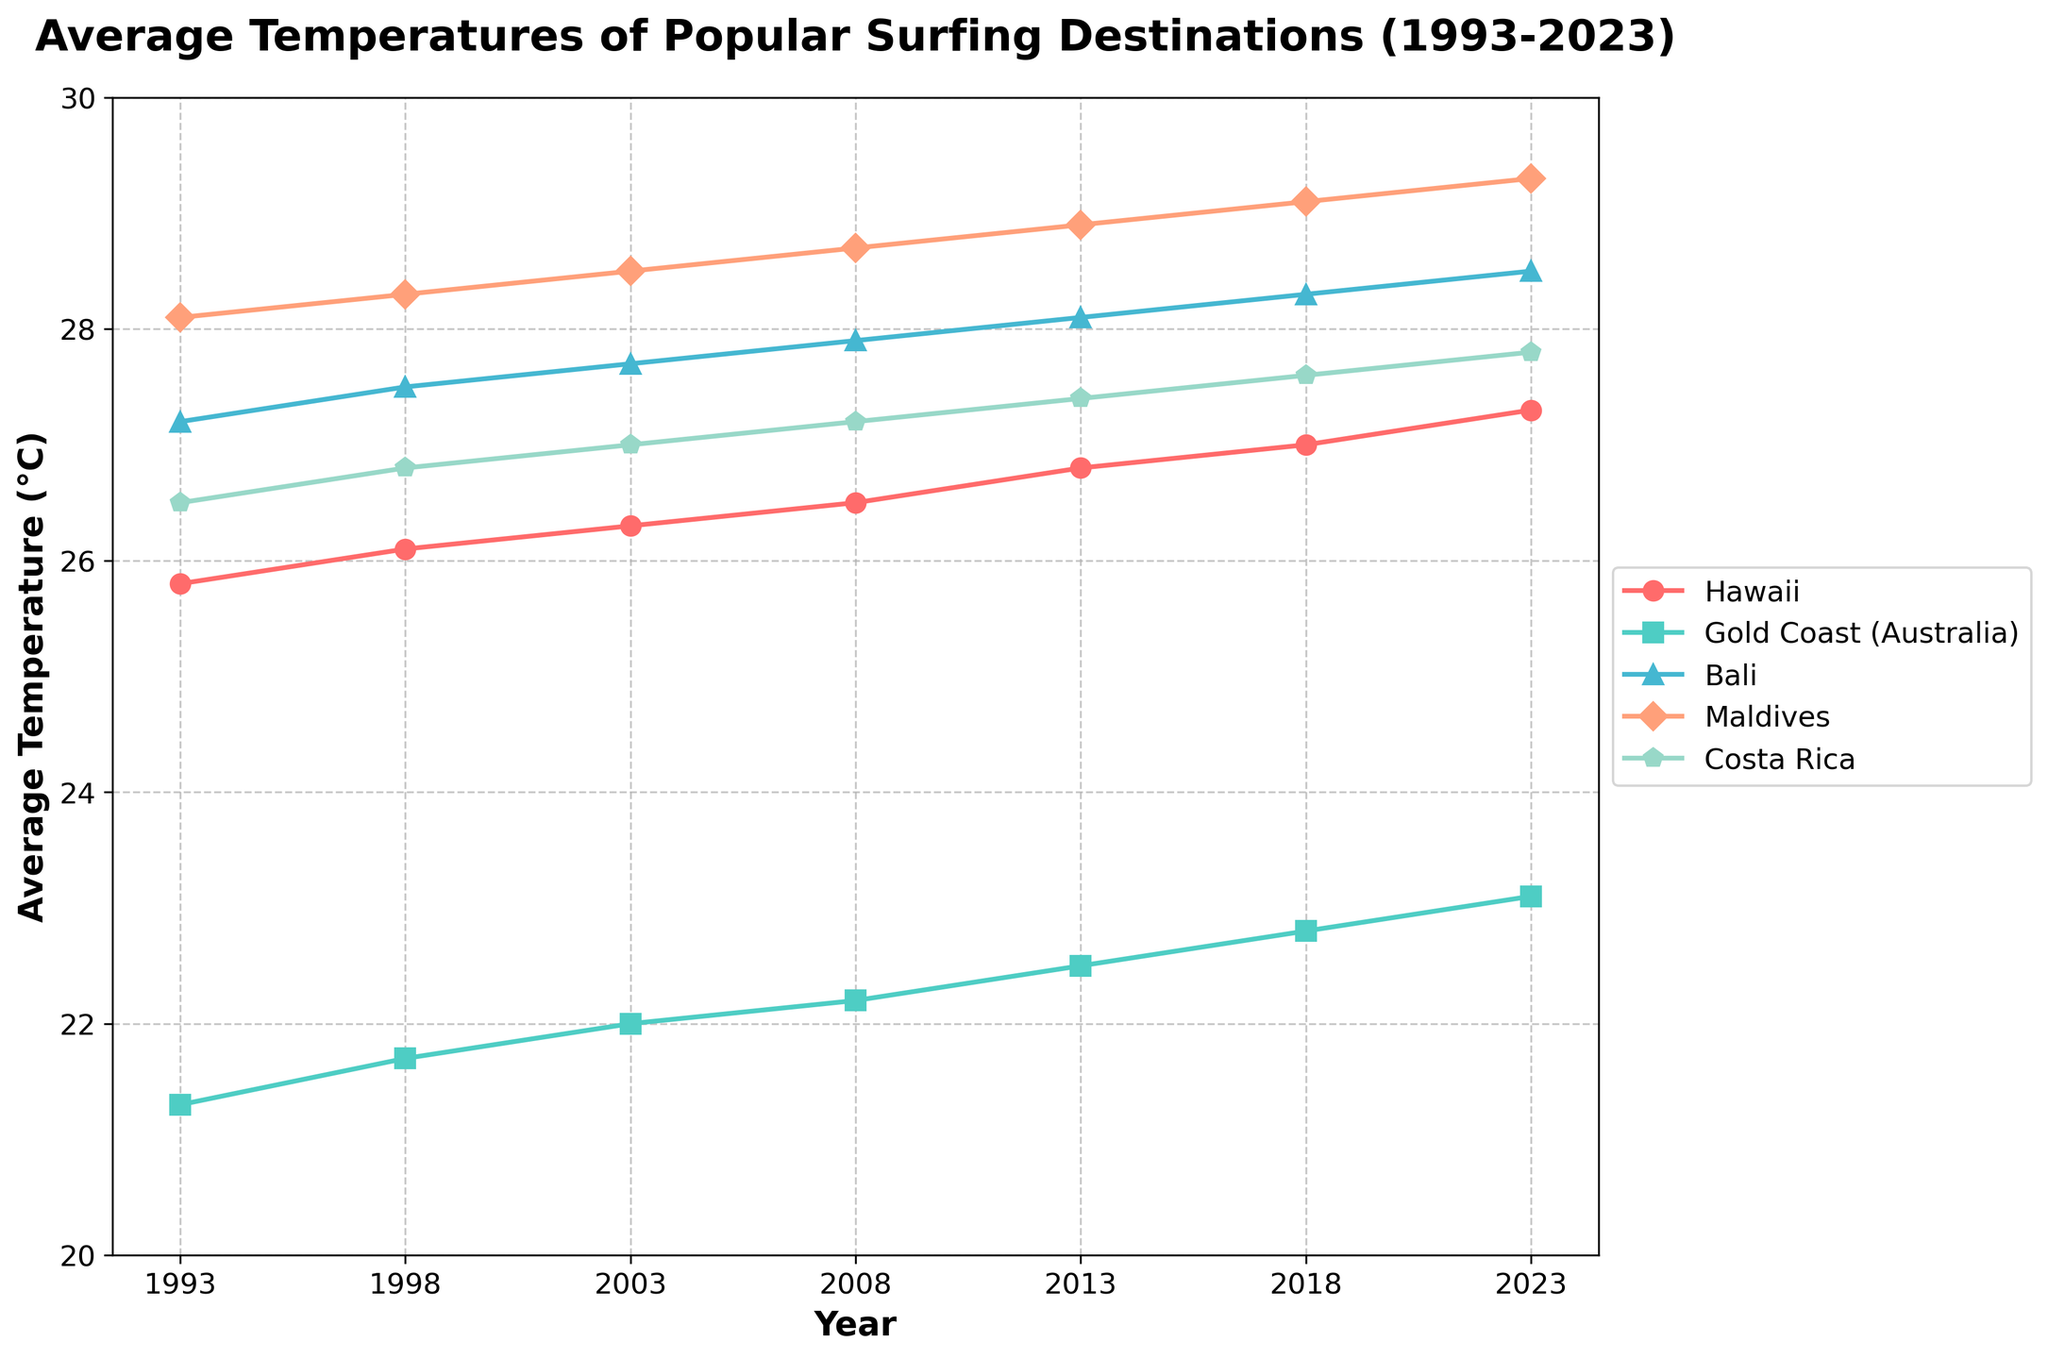Which destination has the highest average temperature in 2023? Looking at the figure, observe which line reaches the highest point in 2023. The Maldives' line is at the top, indicating it has the highest average temperature in that year.
Answer: Maldives How much did the average temperature in Hawaii change from 1993 to 2023? Compare the data points for Hawaii in 1993 and 2023. The temperature in 1993 was 25.8°C, while in 2023 it was 27.3°C. Subtract the earlier temperature from the later temperature: 27.3 - 25.8 = 1.5°C.
Answer: 1.5°C In which year did Gold Coast (Australia) first exceed an average temperature of 22°C? Look for when the Gold Coast's line crosses the 22°C mark. Following from left to right, this occurs around 2008.
Answer: 2008 Between which two consecutive years did Bali see the largest increase in average temperature? Analyze the changes in Bali's temperatures year by year. The biggest jump is between 2013 (28.1°C) and 2018 (28.3°C), with an increase of 0.2°C.
Answer: 2013 and 2018 Which destination showed the least overall temperature change from 1993 to 2023? Evaluate each destination’s temperature changes over the years. The smallest change is seen in Costa Rica: 27.8°C in 2023 minus 26.5°C in 1993 gives 1.3°C. Comparing this with other destinations, it's the lowest change.
Answer: Costa Rica What is the average temperature in the Maldives across all reported years? Sum the Maldives temperatures: 28.1 + 28.3 + 28.5 + 28.7 + 28.9 + 29.1 + 29.3 = 201.9. Divide by the number of years (7): 201.9 / 7 ≈ 28.84°C.
Answer: 28.84°C Which year shows the smallest difference in average temperature between Hawaii and Costa Rica? Find the years where Hawaii and Costa Rica temperatures are closest. In 2018: Hawaii 27.0°C - Costa Rica 27.6°C = 0.6°C. This is the smallest difference compared to other years.
Answer: 2018 